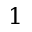<formula> <loc_0><loc_0><loc_500><loc_500>1</formula> 